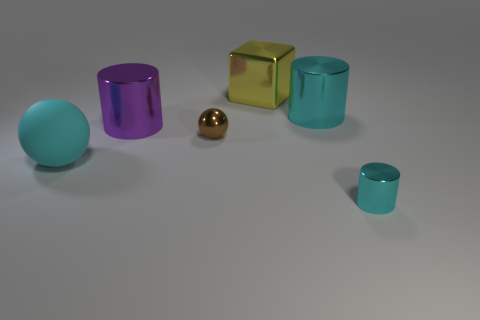Subtract all cyan spheres. How many cyan cylinders are left? 2 Add 3 rubber things. How many objects exist? 9 Subtract all cyan metal cylinders. How many cylinders are left? 1 Subtract all cyan balls. How many balls are left? 1 Subtract all blocks. How many objects are left? 5 Subtract 2 cylinders. How many cylinders are left? 1 Subtract all brown cubes. Subtract all purple cylinders. How many cubes are left? 1 Subtract all big matte balls. Subtract all big cylinders. How many objects are left? 3 Add 5 spheres. How many spheres are left? 7 Add 4 tiny green metal blocks. How many tiny green metal blocks exist? 4 